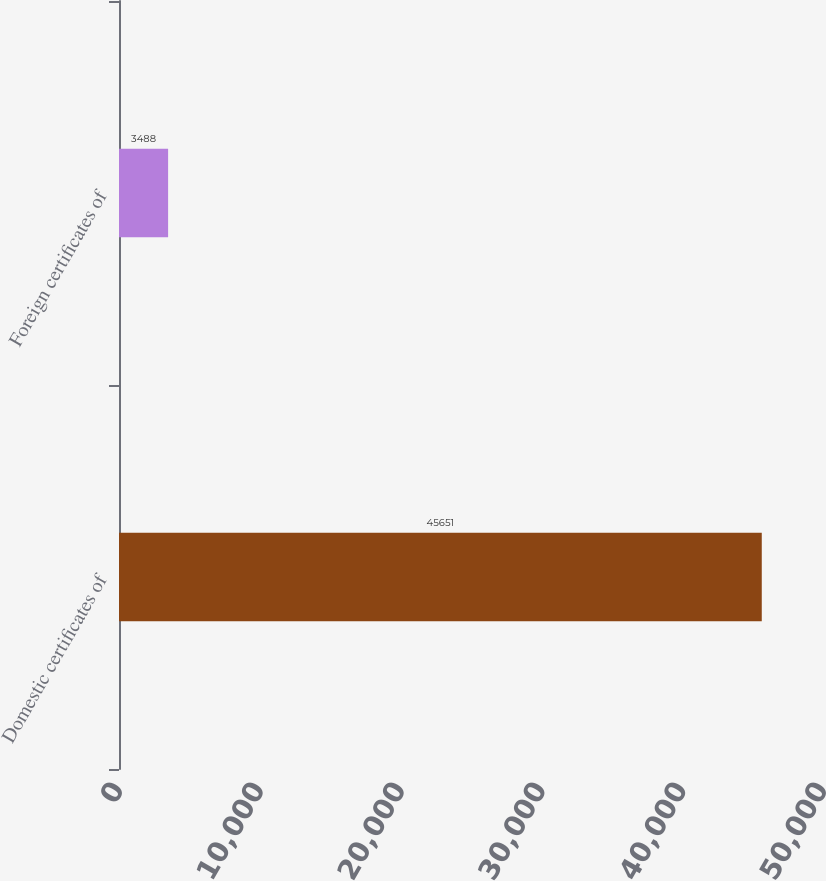Convert chart to OTSL. <chart><loc_0><loc_0><loc_500><loc_500><bar_chart><fcel>Domestic certificates of<fcel>Foreign certificates of<nl><fcel>45651<fcel>3488<nl></chart> 